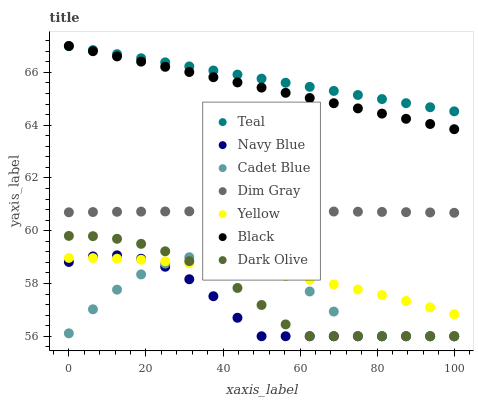Does Navy Blue have the minimum area under the curve?
Answer yes or no. Yes. Does Teal have the maximum area under the curve?
Answer yes or no. Yes. Does Dark Olive have the minimum area under the curve?
Answer yes or no. No. Does Dark Olive have the maximum area under the curve?
Answer yes or no. No. Is Black the smoothest?
Answer yes or no. Yes. Is Cadet Blue the roughest?
Answer yes or no. Yes. Is Navy Blue the smoothest?
Answer yes or no. No. Is Navy Blue the roughest?
Answer yes or no. No. Does Navy Blue have the lowest value?
Answer yes or no. Yes. Does Yellow have the lowest value?
Answer yes or no. No. Does Teal have the highest value?
Answer yes or no. Yes. Does Navy Blue have the highest value?
Answer yes or no. No. Is Dark Olive less than Dim Gray?
Answer yes or no. Yes. Is Black greater than Dim Gray?
Answer yes or no. Yes. Does Teal intersect Black?
Answer yes or no. Yes. Is Teal less than Black?
Answer yes or no. No. Is Teal greater than Black?
Answer yes or no. No. Does Dark Olive intersect Dim Gray?
Answer yes or no. No. 